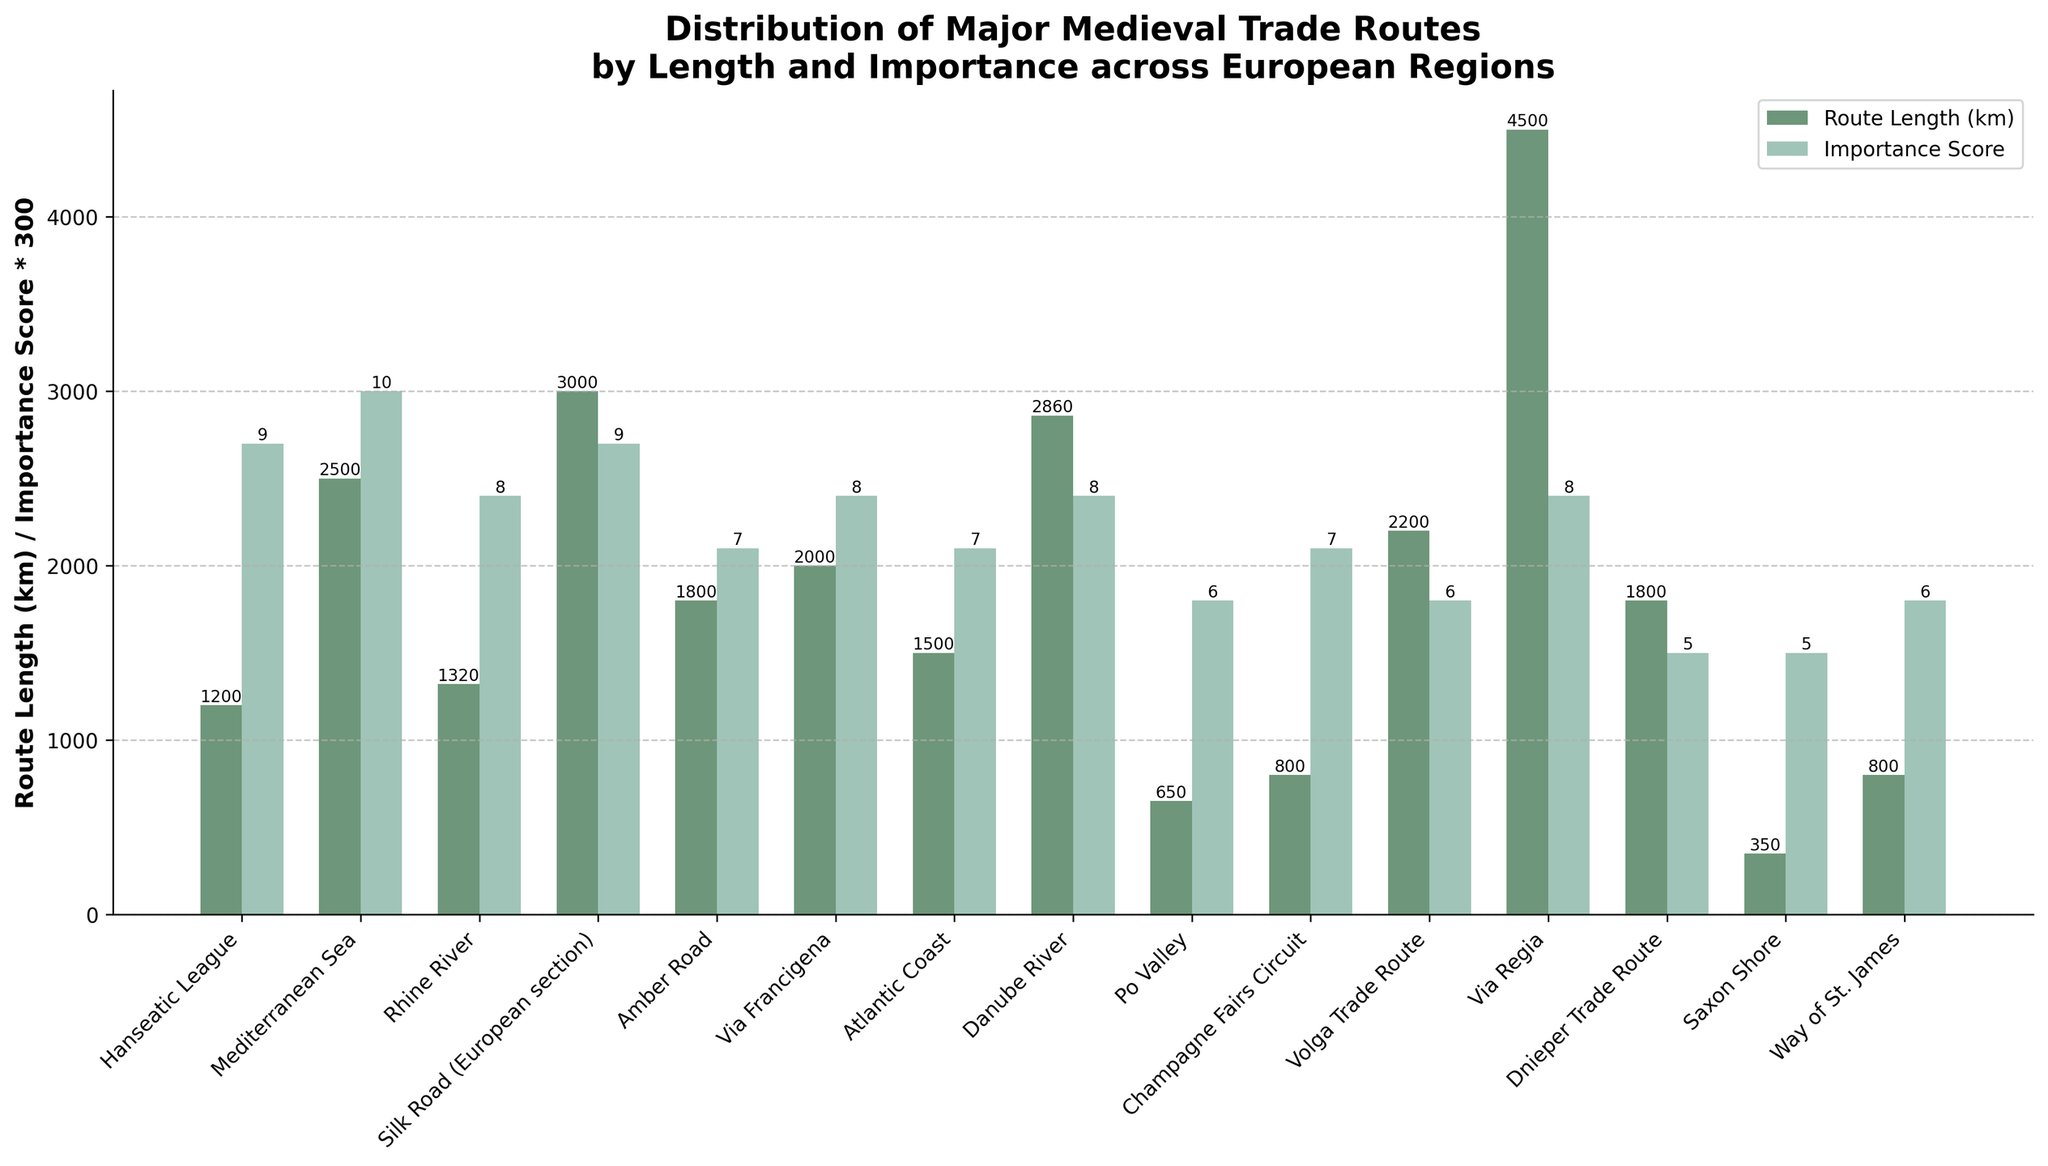Which region has the longest trade route? Compare the heights of the bars representing the route lengths. The tallest bar is for the region with the longest trade route. In this plot, "Via Regia" has the tallest bar for route length.
Answer: Via Regia Which trade route has the highest importance score? Compare the heights of the bars representing the importance scores (scaled by 300). The tallest bar for importance score is for the "Mediterranean Sea" region.
Answer: Mediterranean Sea What’s the sum of the route lengths for the Hanseatic League and the Po Valley? Add the route lengths of Hanseatic League (1200 km) and Po Valley (650 km). 1200 + 650 = 1850 km.
Answer: 1850 km Which region has both route length and importance score above average? Calculate the average route length and importance score. Then identify the regions with both measures above these averages. Average route length = 1798.67 km, Average importance score = 7.07. The regions matching this criteria are "Mediterranean Sea" and "Silk Road (European section)".
Answer: Mediterranean Sea, Silk Road (European section) How does the route length of the Champagne Fairs Circuit compare to the Via Francigena? Compare the heights of the bars for Champagne Fairs Circuit (800 km) and Via Francigena (2000 km). Champagne Fairs Circuit's bar is significantly shorter.
Answer: Champagne Fairs Circuit is shorter What is the difference in the importance score between the Danube River and the Via Regia? Subtract the importance score of Via Regia (8) from that of the Danube River (8). 8 - 8 = 0.
Answer: 0 Which regions' trade routes have lengths closest to 2000 km? Identify the regions with route lengths close to 2000 km by comparing the bar lengths. The regions are "Via Francigena" (2000 km) and "Volga Trade Route" (2200 km).
Answer: Via Francigena, Volga Trade Route What is the combined importance score of the Saxon Shore and the Way of St. James? Add the importance scores of the Saxon Shore (5) and the Way of St. James (6). 5 + 6 = 11.
Answer: 11 Which region has the lowest importance score? Identify the region with the shortest bar representing importance scores. The shortest bar is for "Dnieper Trade Route" with an importance score of 5.
Answer: Dnieper Trade Route How does the importance score of the Amber Road compare to the Rhine River? Compare the heights of the bars for Amber Road (7) and Rhine River (8). The importance score of the Amber Road is lower than that of the Rhine River.
Answer: Amber Road is lower 